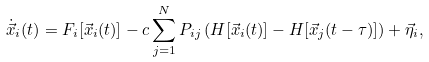<formula> <loc_0><loc_0><loc_500><loc_500>\dot { \vec { x } } _ { i } ( t ) = F _ { i } [ \vec { x } _ { i } ( t ) ] - c \sum _ { j = 1 } ^ { N } P _ { i j } \left ( H [ \vec { x } _ { i } ( t ) ] - H [ \vec { x } _ { j } ( t - \tau ) ] \right ) + \vec { \eta } _ { i } ,</formula> 